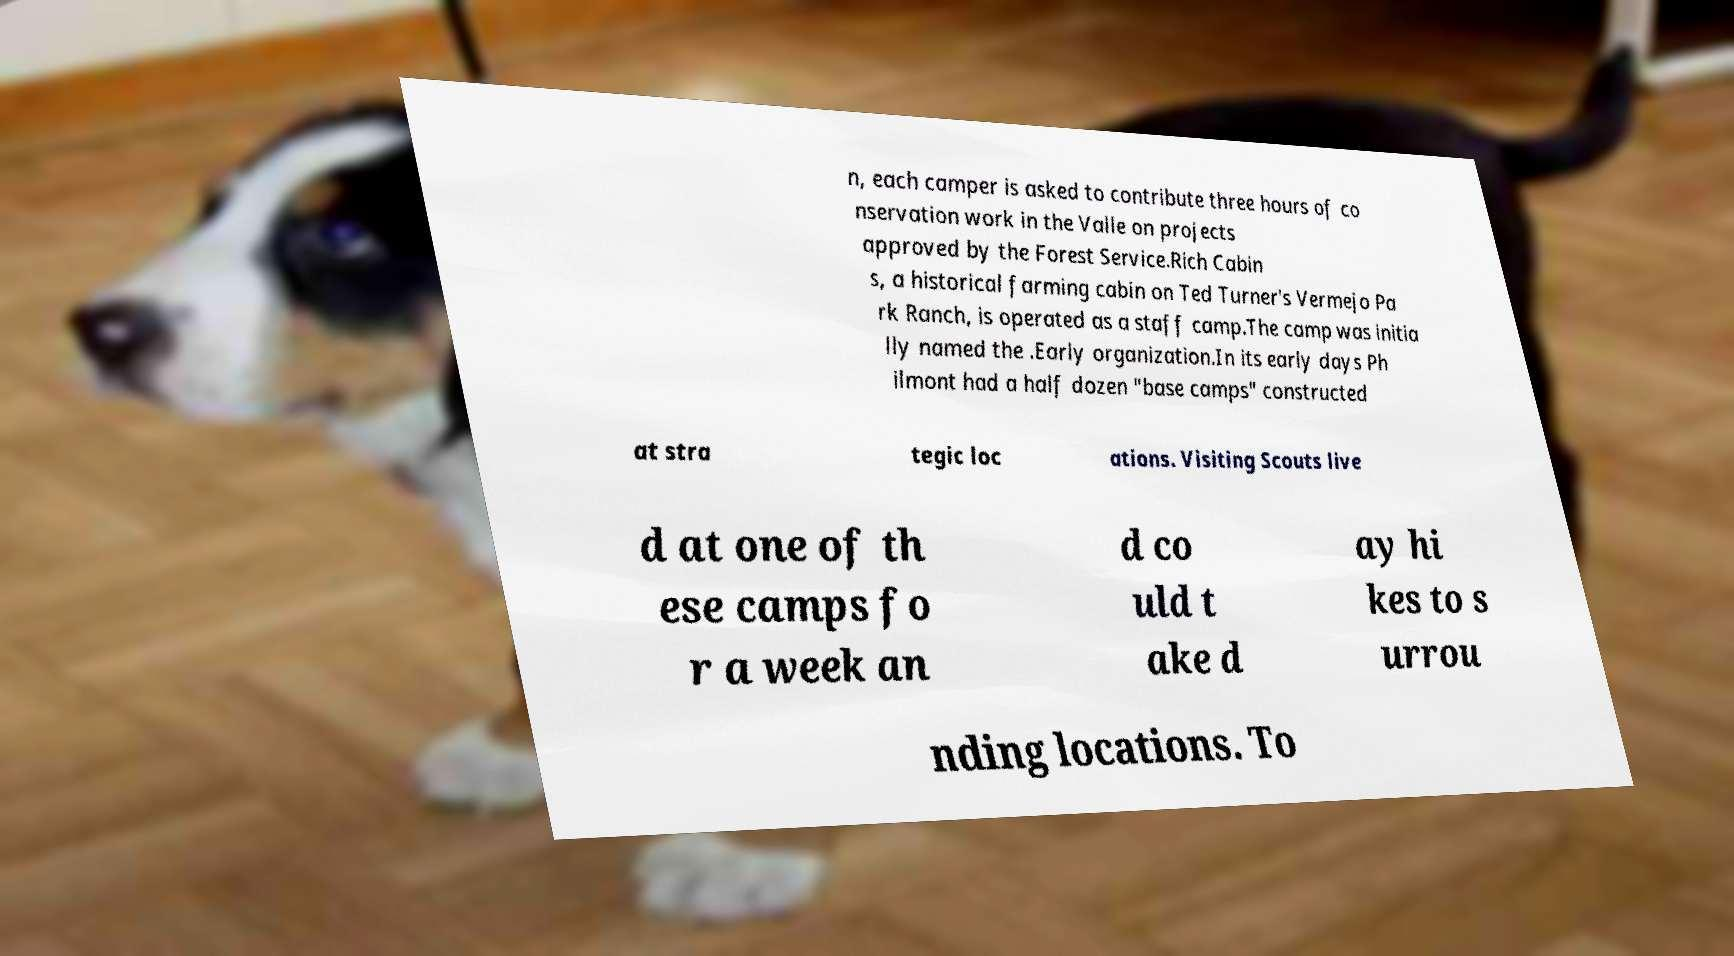Please read and relay the text visible in this image. What does it say? n, each camper is asked to contribute three hours of co nservation work in the Valle on projects approved by the Forest Service.Rich Cabin s, a historical farming cabin on Ted Turner's Vermejo Pa rk Ranch, is operated as a staff camp.The camp was initia lly named the .Early organization.In its early days Ph ilmont had a half dozen "base camps" constructed at stra tegic loc ations. Visiting Scouts live d at one of th ese camps fo r a week an d co uld t ake d ay hi kes to s urrou nding locations. To 